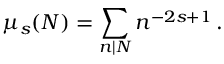Convert formula to latex. <formula><loc_0><loc_0><loc_500><loc_500>\mu _ { s } ( N ) = \sum _ { n | N } n ^ { - 2 s + 1 } \, .</formula> 